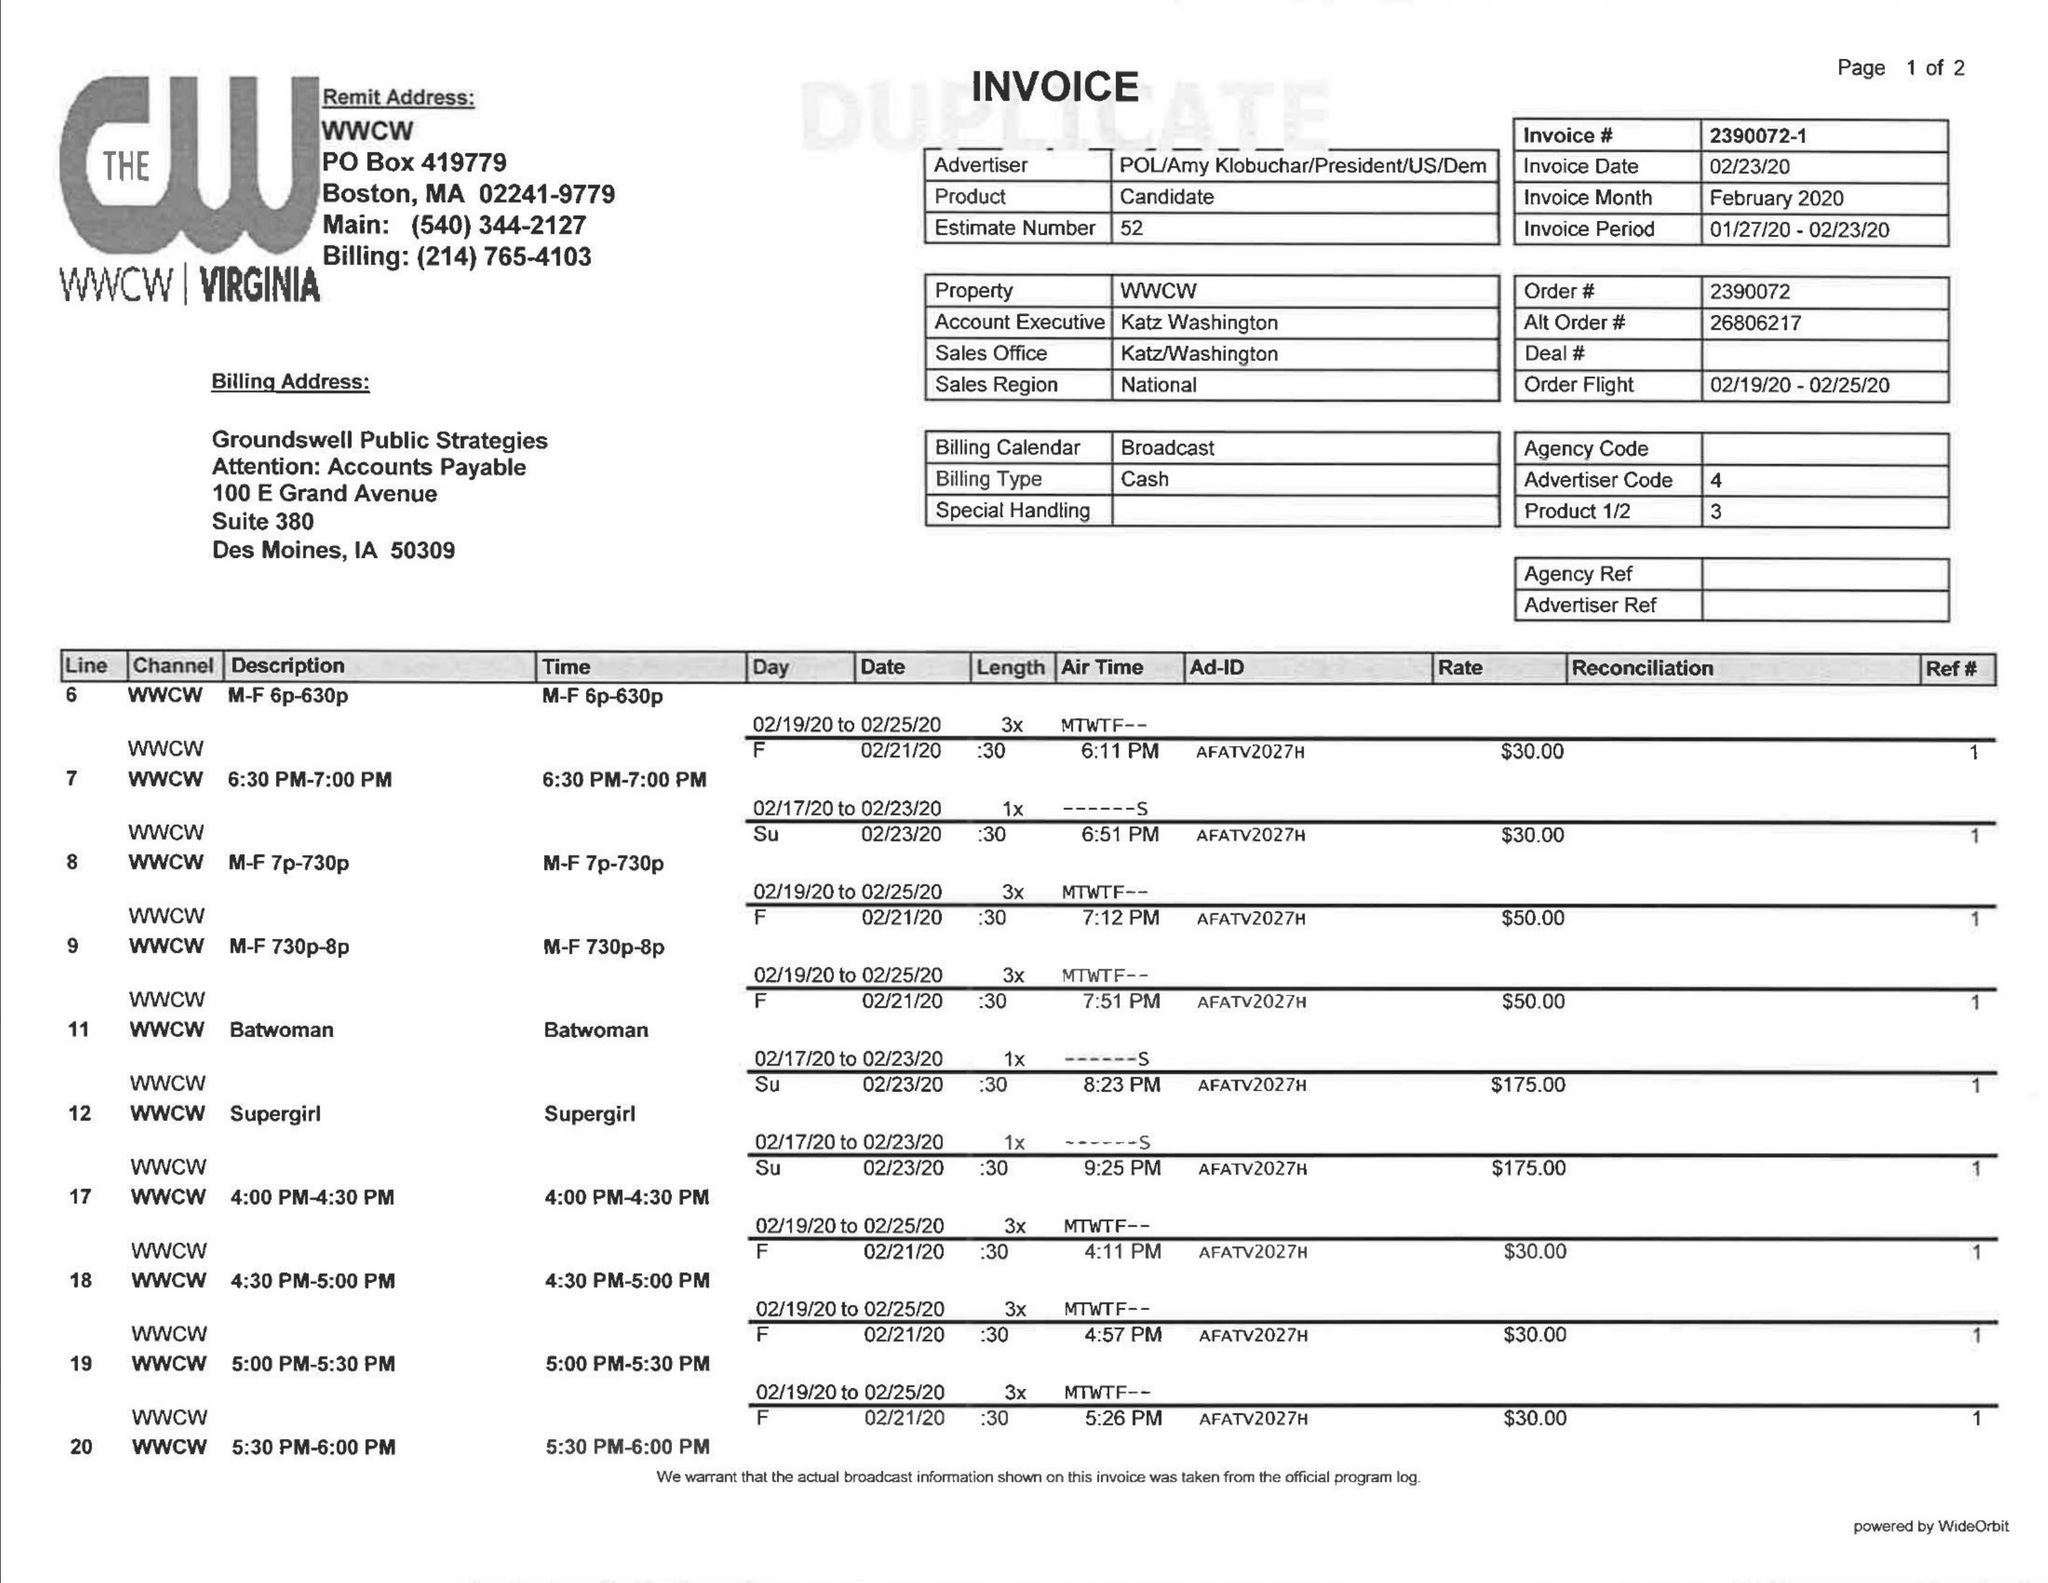What is the value for the contract_num?
Answer the question using a single word or phrase. 2390072 